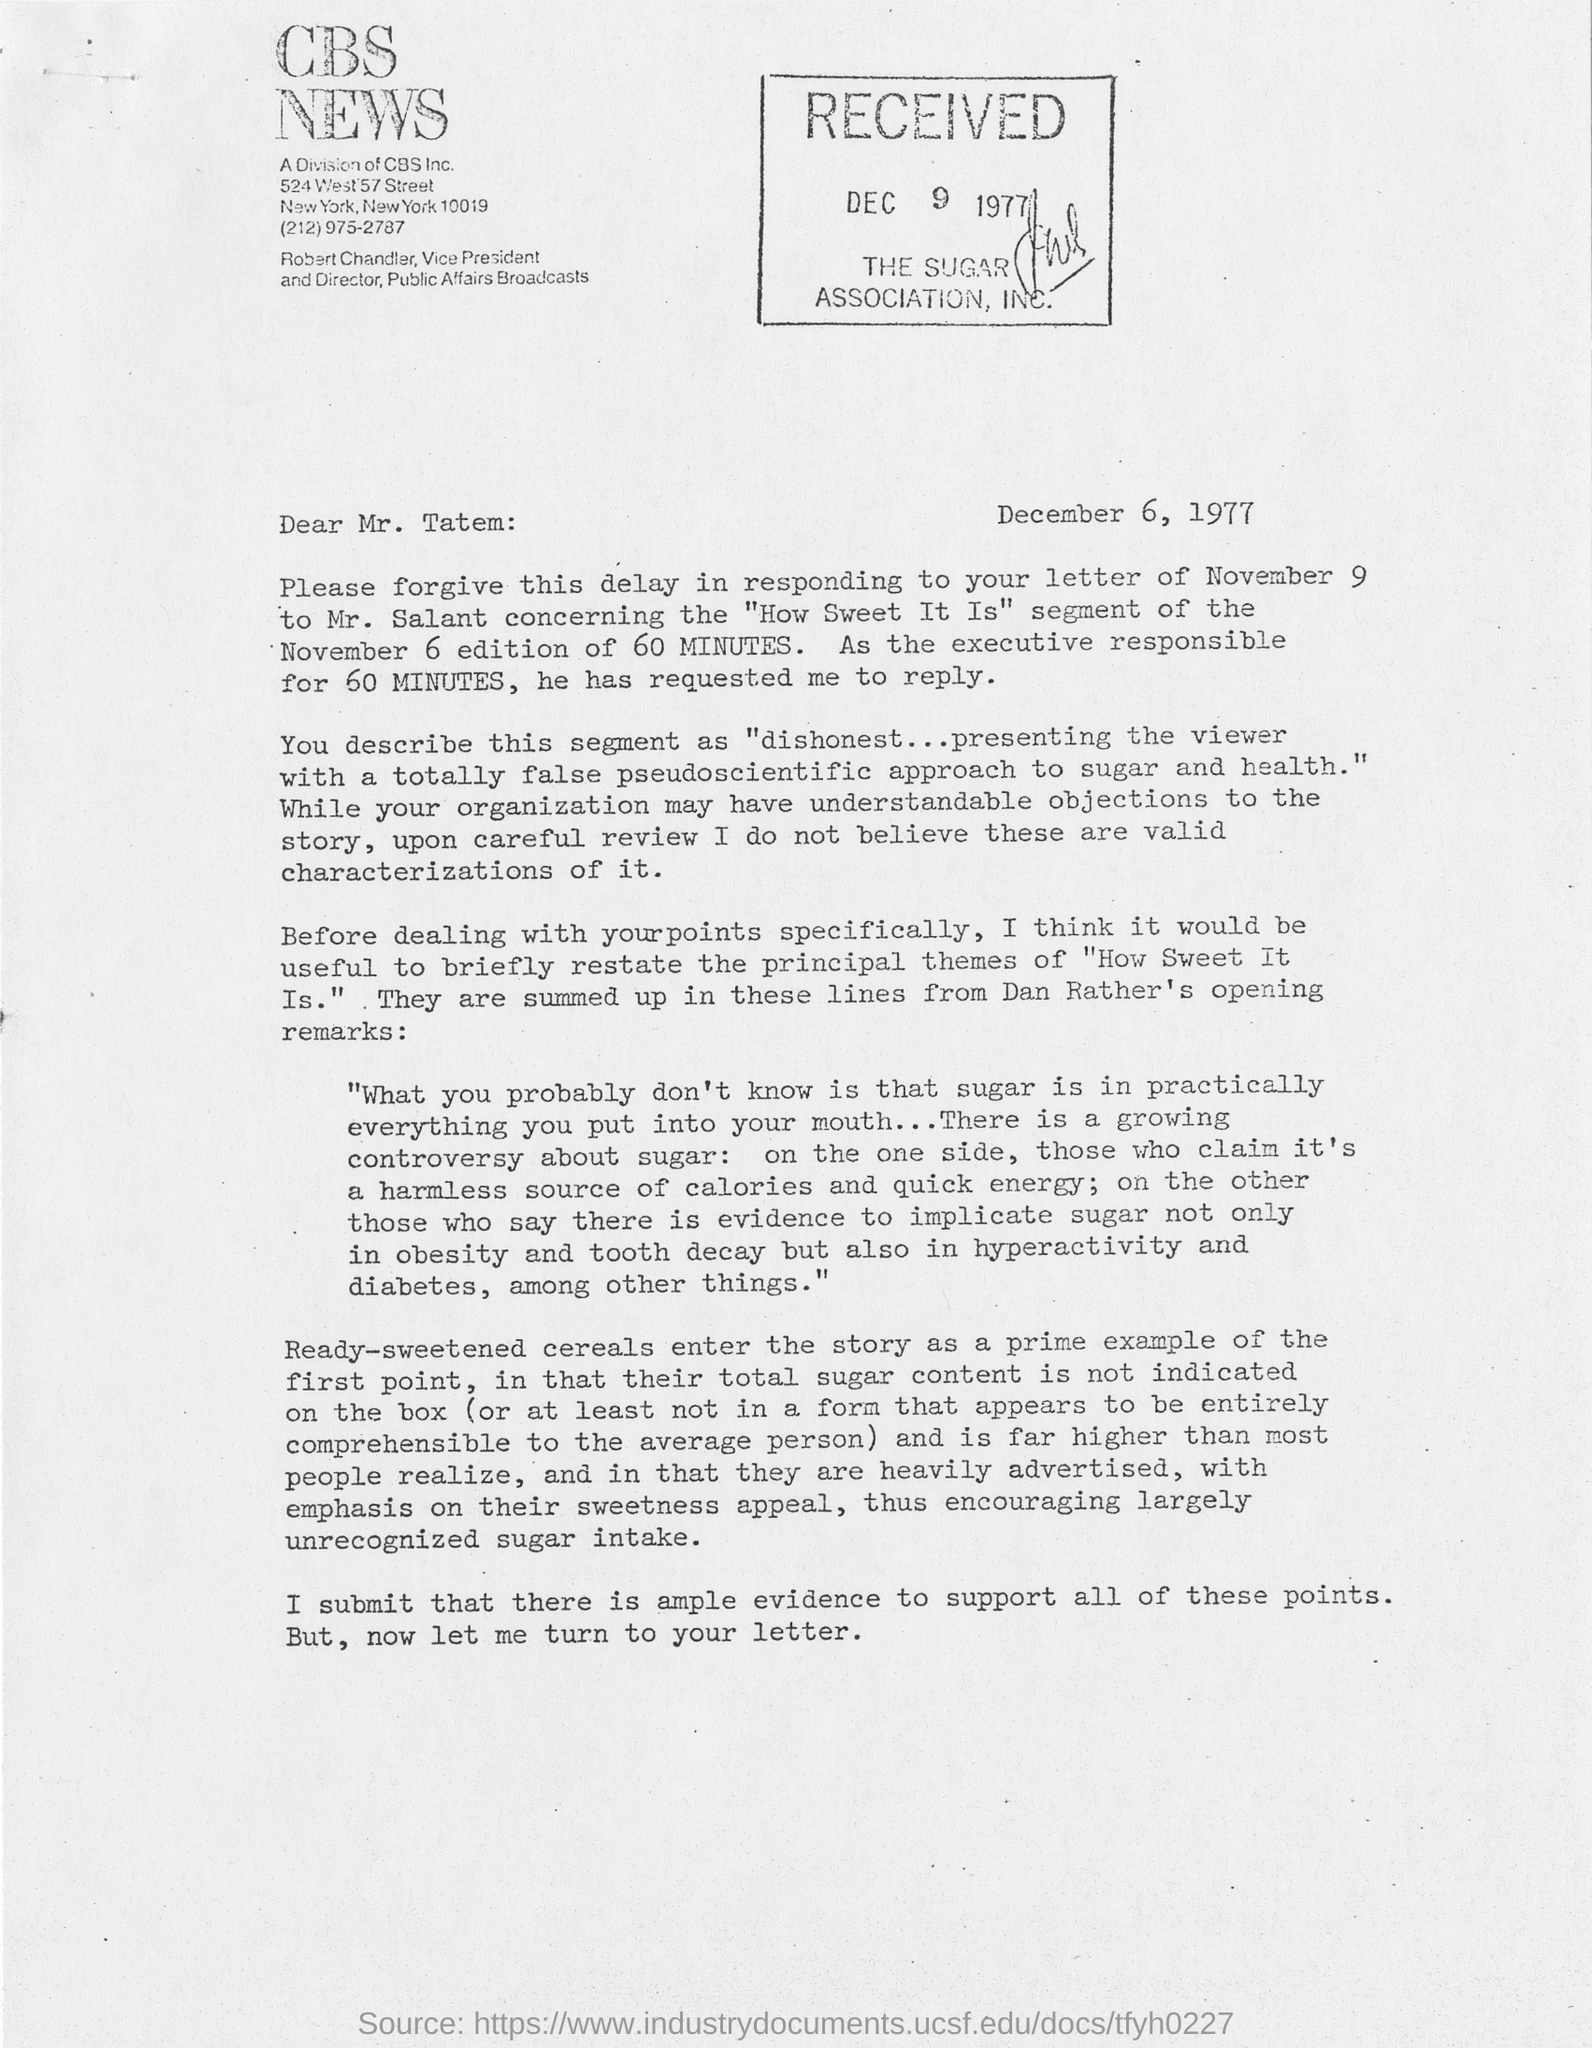Point out several critical features in this image. CBS News is the name of a company. The letter is addressed to Mr. Tatem. The date of this letter is December 6, 1977. The received date of this letter is December 9, 1977. 